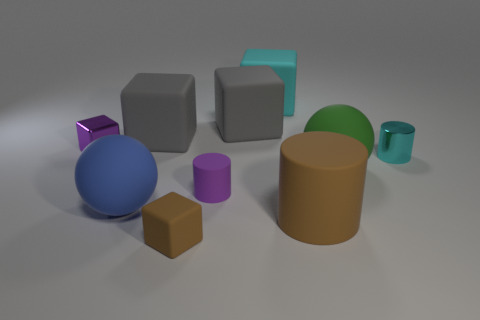What number of rubber blocks have the same color as the large matte cylinder?
Provide a short and direct response. 1. There is a thing that is the same color as the tiny metallic cube; what is it made of?
Provide a short and direct response. Rubber. What is the shape of the rubber thing that is in front of the big brown rubber cylinder behind the rubber block that is in front of the large blue sphere?
Your answer should be very brief. Cube. There is another large object that is the same shape as the blue matte thing; what material is it?
Your answer should be compact. Rubber. How many large gray blocks are there?
Ensure brevity in your answer.  2. There is a brown rubber object that is on the left side of the small purple rubber object; what is its shape?
Your response must be concise. Cube. The rubber sphere that is in front of the purple object that is in front of the metallic thing that is in front of the purple metallic thing is what color?
Provide a succinct answer. Blue. There is a brown object that is the same material as the brown cylinder; what is its shape?
Offer a very short reply. Cube. Are there fewer big matte cylinders than small green matte spheres?
Your answer should be very brief. No. Are the purple cylinder and the large green sphere made of the same material?
Make the answer very short. Yes. 